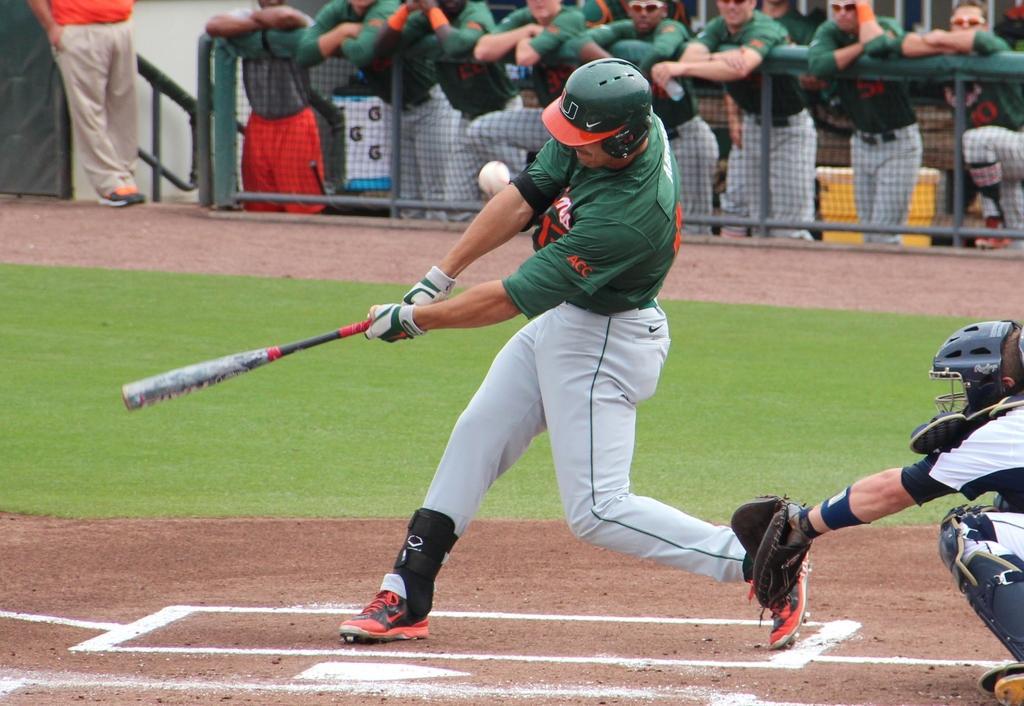Can you describe this image briefly? In the picture I can see a person wearing green color helmet is standing and holding a baseball bat in his hands and there is a ball in front of him and there is a person standing behind him in the right corner and there is a fence and few persons in the background. 